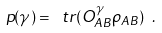<formula> <loc_0><loc_0><loc_500><loc_500>p ( \gamma ) = \ t r ( O ^ { \gamma } _ { A B } \rho _ { A B } ) \ .</formula> 